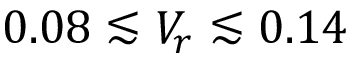Convert formula to latex. <formula><loc_0><loc_0><loc_500><loc_500>0 . 0 8 \lesssim V _ { r } \lesssim 0 . 1 4</formula> 